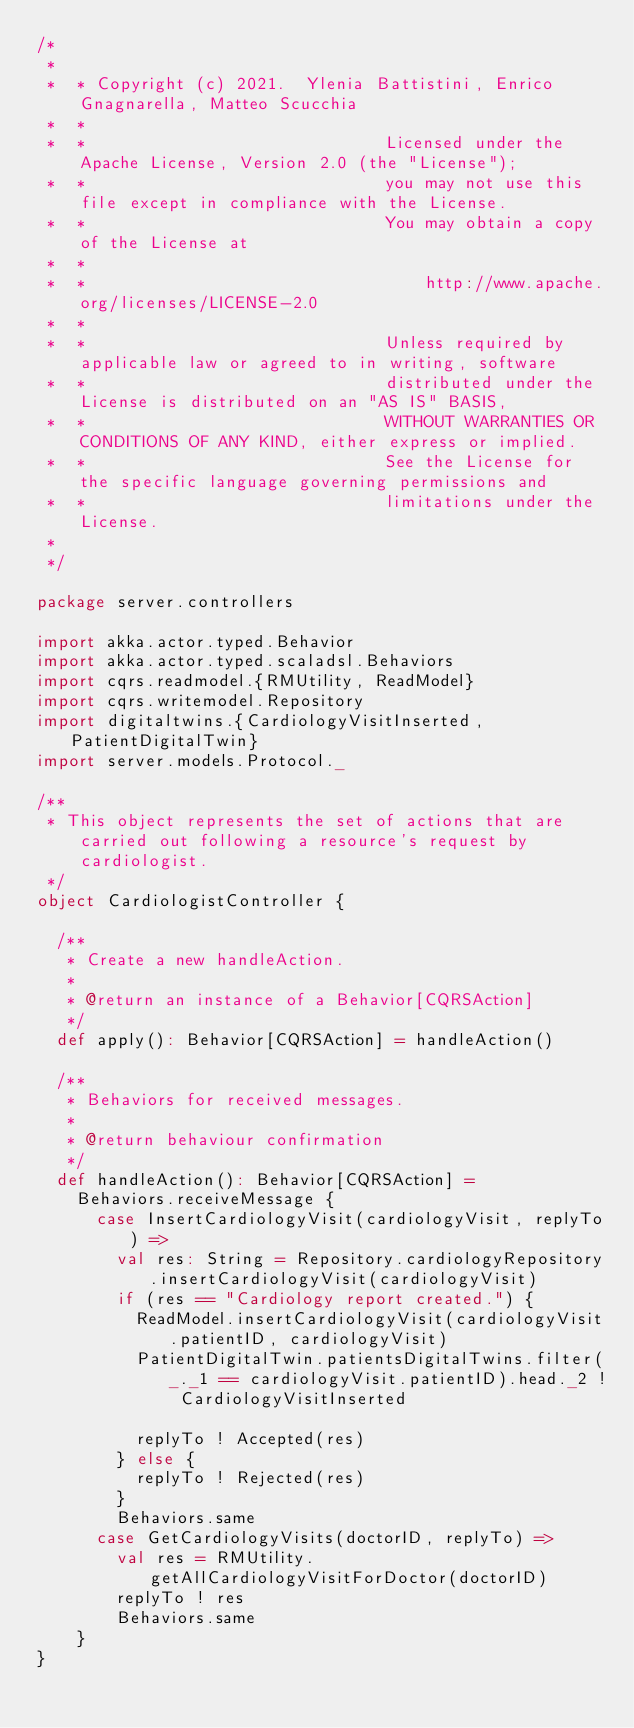<code> <loc_0><loc_0><loc_500><loc_500><_Scala_>/*
 *
 *  * Copyright (c) 2021.  Ylenia Battistini, Enrico Gnagnarella, Matteo Scucchia
 *  *
 *  *                              Licensed under the Apache License, Version 2.0 (the "License");
 *  *                              you may not use this file except in compliance with the License.
 *  *                              You may obtain a copy of the License at
 *  *
 *  *                                  http://www.apache.org/licenses/LICENSE-2.0
 *  *
 *  *                              Unless required by applicable law or agreed to in writing, software
 *  *                              distributed under the License is distributed on an "AS IS" BASIS,
 *  *                              WITHOUT WARRANTIES OR CONDITIONS OF ANY KIND, either express or implied.
 *  *                              See the License for the specific language governing permissions and
 *  *                              limitations under the License.
 *
 */

package server.controllers

import akka.actor.typed.Behavior
import akka.actor.typed.scaladsl.Behaviors
import cqrs.readmodel.{RMUtility, ReadModel}
import cqrs.writemodel.Repository
import digitaltwins.{CardiologyVisitInserted, PatientDigitalTwin}
import server.models.Protocol._

/**
 * This object represents the set of actions that are carried out following a resource's request by cardiologist.
 */
object CardiologistController {

  /**
   * Create a new handleAction.
   *
   * @return an instance of a Behavior[CQRSAction]
   */
  def apply(): Behavior[CQRSAction] = handleAction()

  /**
   * Behaviors for received messages.
   *
   * @return behaviour confirmation
   */
  def handleAction(): Behavior[CQRSAction] =
    Behaviors.receiveMessage {
      case InsertCardiologyVisit(cardiologyVisit, replyTo) =>
        val res: String = Repository.cardiologyRepository.insertCardiologyVisit(cardiologyVisit)
        if (res == "Cardiology report created.") {
          ReadModel.insertCardiologyVisit(cardiologyVisit.patientID, cardiologyVisit)
          PatientDigitalTwin.patientsDigitalTwins.filter(_._1 == cardiologyVisit.patientID).head._2 ! CardiologyVisitInserted

          replyTo ! Accepted(res)
        } else {
          replyTo ! Rejected(res)
        }
        Behaviors.same
      case GetCardiologyVisits(doctorID, replyTo) =>
        val res = RMUtility.getAllCardiologyVisitForDoctor(doctorID)
        replyTo ! res
        Behaviors.same
    }
}
</code> 